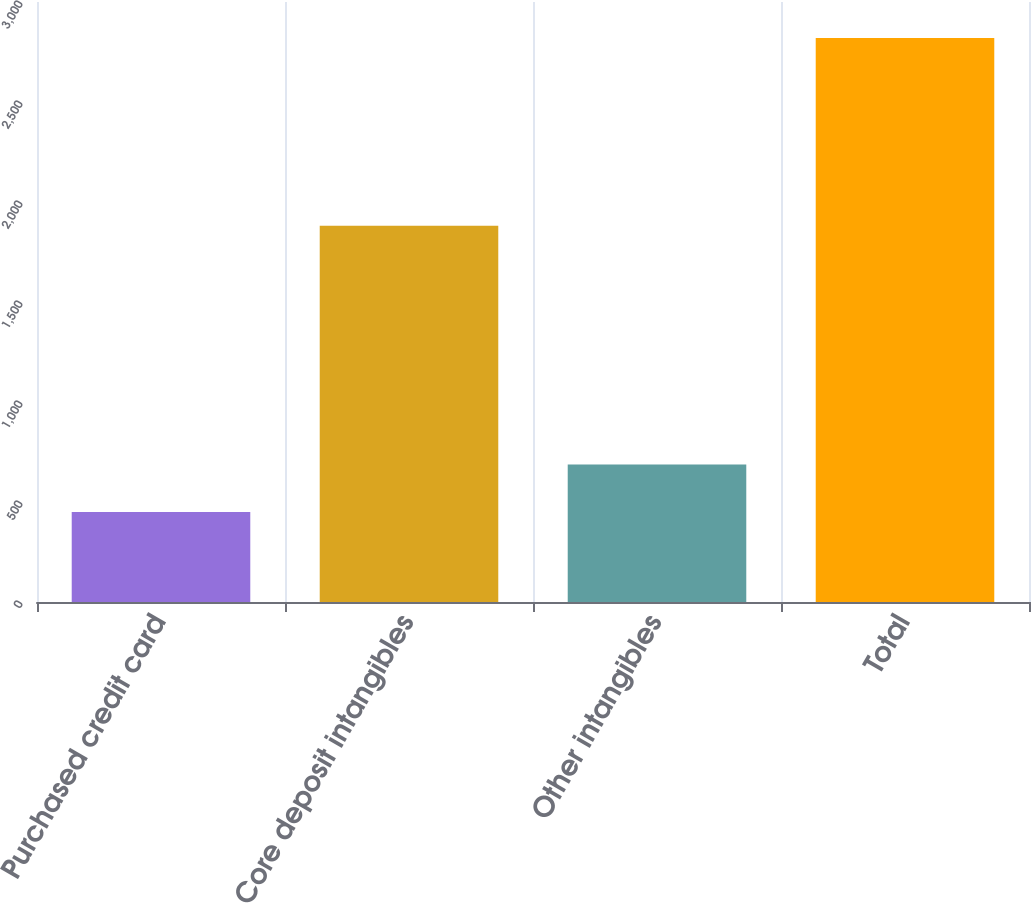<chart> <loc_0><loc_0><loc_500><loc_500><bar_chart><fcel>Purchased credit card<fcel>Core deposit intangibles<fcel>Other intangibles<fcel>Total<nl><fcel>450<fcel>1881<fcel>687<fcel>2820<nl></chart> 